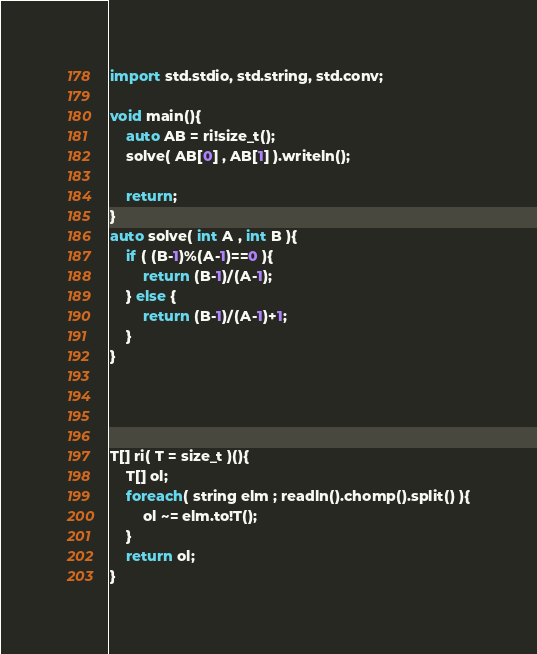<code> <loc_0><loc_0><loc_500><loc_500><_D_>import std.stdio, std.string, std.conv;

void main(){
	auto AB = ri!size_t();
	solve( AB[0] , AB[1] ).writeln();
	
	return;
}
auto solve( int A , int B ){
	if ( (B-1)%(A-1)==0 ){
		return (B-1)/(A-1);
	} else {
		return (B-1)/(A-1)+1;
	}
}




T[] ri( T = size_t )(){
	T[] ol;
	foreach( string elm ; readln().chomp().split() ){
		ol ~= elm.to!T();
	}
	return ol;
}
</code> 